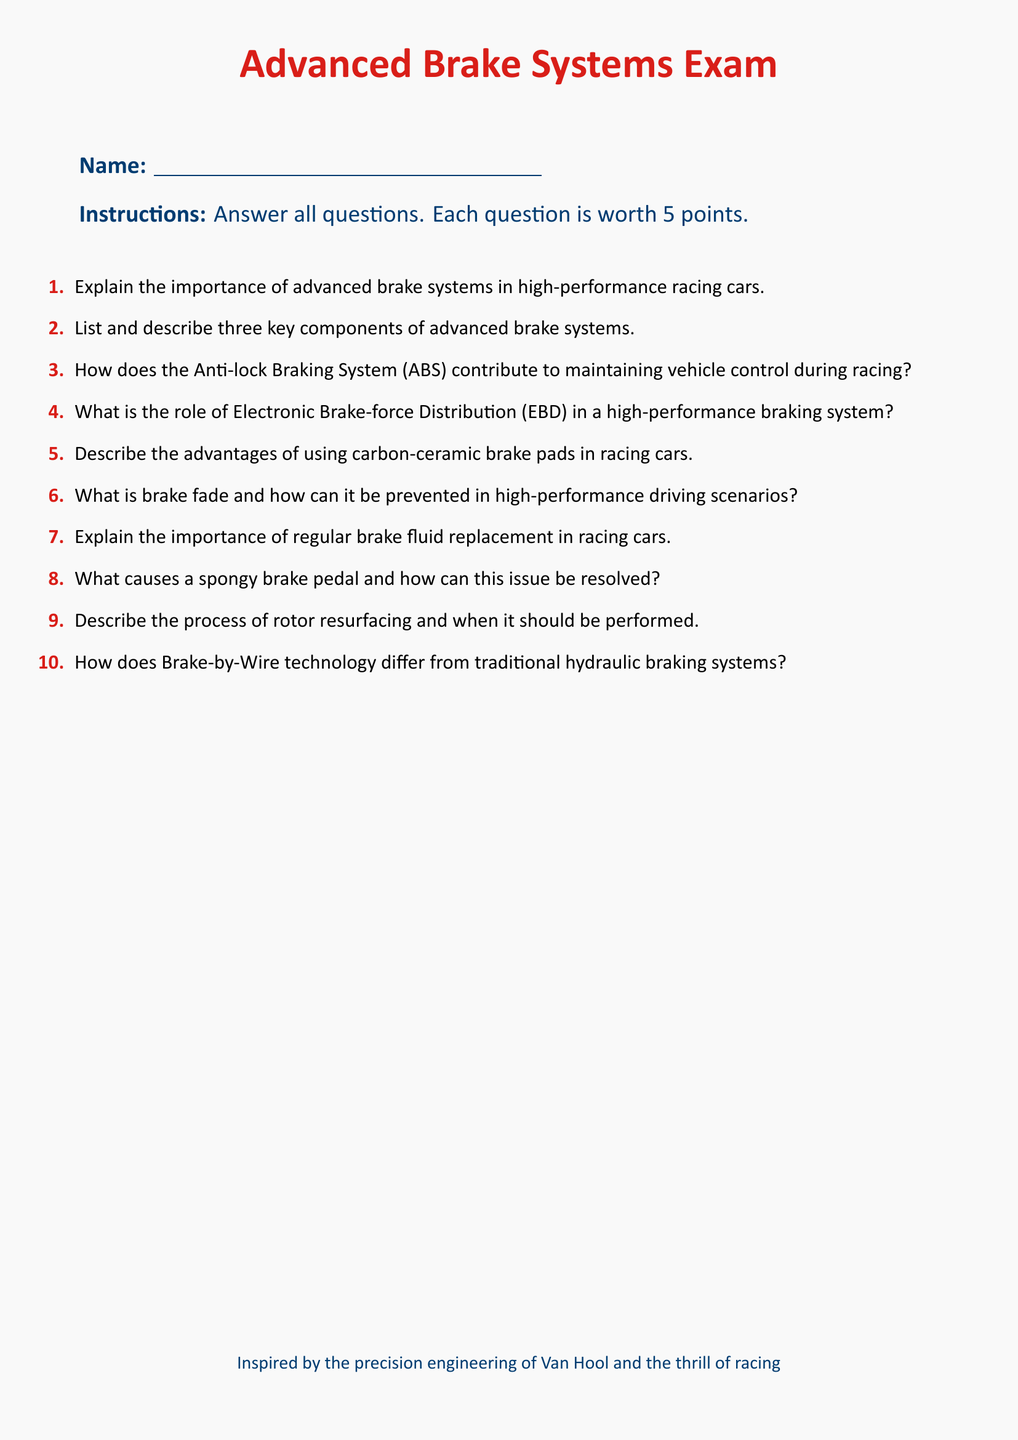What is the title of the document? The title of the document is presented prominently at the top, indicating the subject of the exam.
Answer: Advanced Brake Systems Exam How many questions are included in the exam? The exam contains a total of ten questions as indicated by the enumerated list.
Answer: 10 What color is used for the headings in the exam? The color used for the headings is specified in the document as racing red.
Answer: racing red What is the value of each question in points? The document explicitly states the point value assigned to each question in the instructions section.
Answer: 5 points What is described as an advanced feature in high-performance brake systems? The document lists specific advanced features when discussing various components, one of which is mentioned in the context of vehicle control.
Answer: Anti-lock Braking System (ABS) What component is noted for its advantages in racing cars? The document highlights specific features of certain components that enhance performance in racing environments.
Answer: carbon-ceramic brake pads What maintenance action is emphasized for racing cars? The document underlines the importance of a specific maintenance action related to brake systems within the context of regular upkeep.
Answer: brake fluid replacement What technology differs from traditional braking systems? The document introduces a modern technology that is mentioned as a contrast to traditional methods within the context of braking.
Answer: Brake-by-Wire technology What is one problem that can lead to a malfunction in the braking system? The document discusses specific issues that affect braking performance, identifying one common problem among them.
Answer: spongy brake pedal 